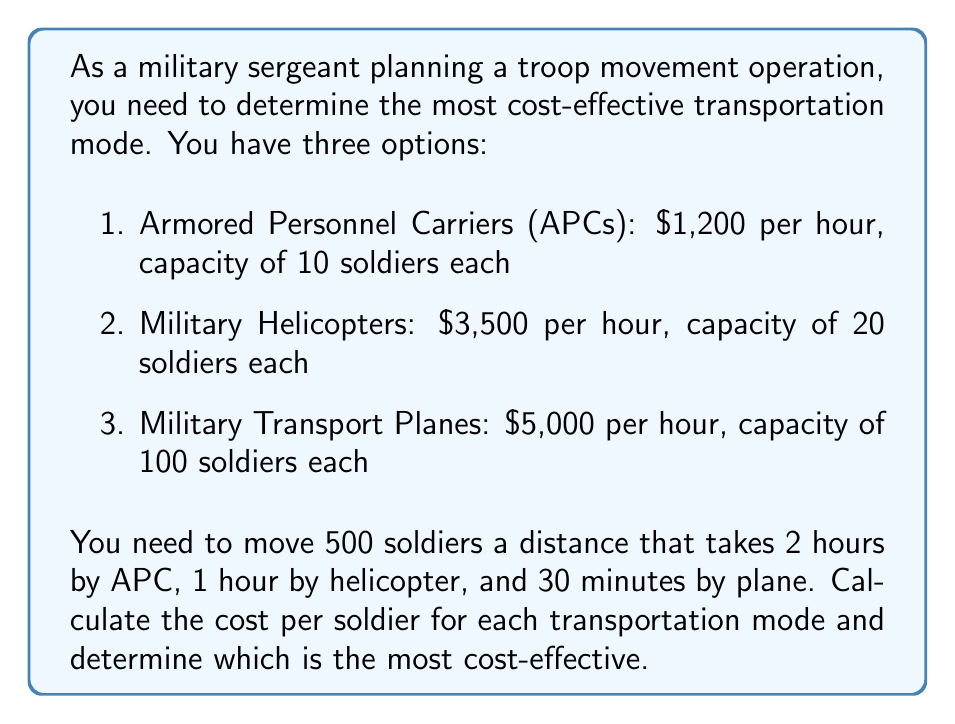What is the answer to this math problem? Let's break this down step-by-step for each transportation mode:

1. Armored Personnel Carriers (APCs):
   - Number of APCs needed: $\frac{500 \text{ soldiers}}{10 \text{ soldiers/APC}} = 50$ APCs
   - Total time: 2 hours
   - Cost per APC: $1,200 \text{ per hour} \times 2 \text{ hours} = \$2,400$
   - Total cost: $50 \text{ APCs} \times \$2,400 = \$120,000$
   - Cost per soldier: $\frac{\$120,000}{500 \text{ soldiers}} = \$240$ per soldier

2. Military Helicopters:
   - Number of helicopters needed: $\frac{500 \text{ soldiers}}{20 \text{ soldiers/helicopter}} = 25$ helicopters
   - Total time: 1 hour
   - Cost per helicopter: $3,500 \text{ per hour} \times 1 \text{ hour} = \$3,500$
   - Total cost: $25 \text{ helicopters} \times \$3,500 = \$87,500$
   - Cost per soldier: $\frac{\$87,500}{500 \text{ soldiers}} = \$175$ per soldier

3. Military Transport Planes:
   - Number of planes needed: $\frac{500 \text{ soldiers}}{100 \text{ soldiers/plane}} = 5$ planes
   - Total time: 0.5 hours
   - Cost per plane: $5,000 \text{ per hour} \times 0.5 \text{ hours} = \$2,500$
   - Total cost: $5 \text{ planes} \times \$2,500 = \$12,500$
   - Cost per soldier: $\frac{\$12,500}{500 \text{ soldiers}} = \$25$ per soldier

Comparing the cost per soldier:
- APCs: $\$240$ per soldier
- Helicopters: $\$175$ per soldier
- Transport Planes: $\$25$ per soldier

The most cost-effective option is the Military Transport Planes at $\$25$ per soldier.
Answer: The most cost-effective transportation mode is Military Transport Planes at $\$25$ per soldier. 